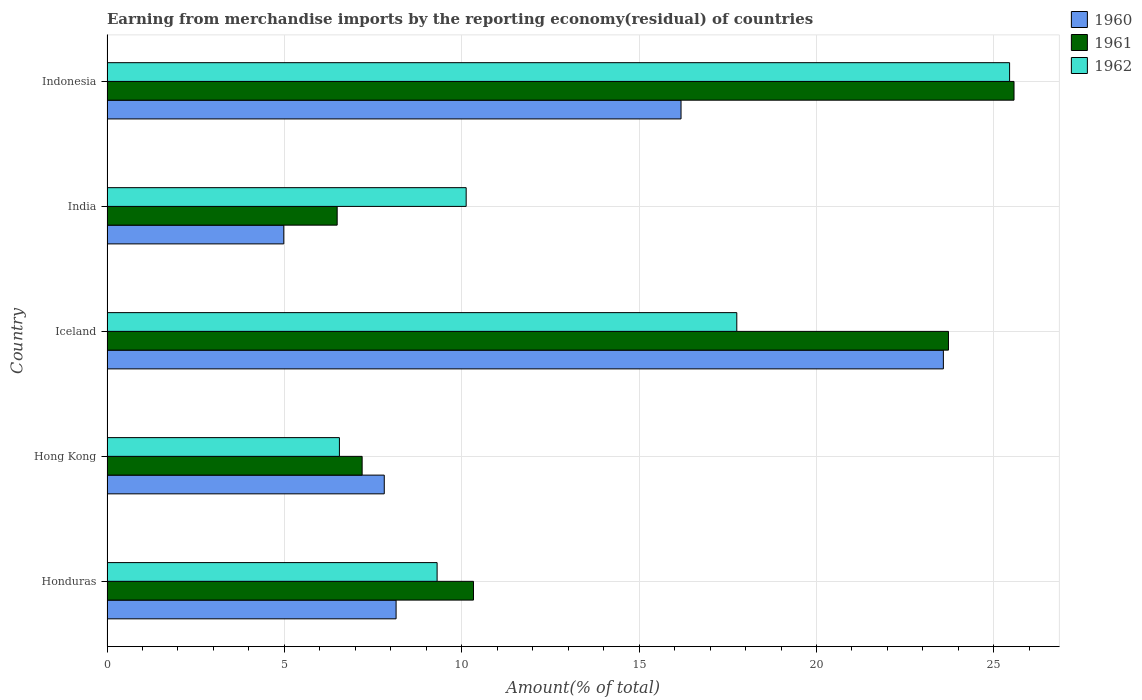How many different coloured bars are there?
Offer a very short reply. 3. Are the number of bars per tick equal to the number of legend labels?
Offer a terse response. Yes. Are the number of bars on each tick of the Y-axis equal?
Offer a very short reply. Yes. What is the label of the 1st group of bars from the top?
Ensure brevity in your answer.  Indonesia. In how many cases, is the number of bars for a given country not equal to the number of legend labels?
Keep it short and to the point. 0. What is the percentage of amount earned from merchandise imports in 1962 in Indonesia?
Offer a terse response. 25.44. Across all countries, what is the maximum percentage of amount earned from merchandise imports in 1962?
Keep it short and to the point. 25.44. Across all countries, what is the minimum percentage of amount earned from merchandise imports in 1962?
Offer a terse response. 6.55. In which country was the percentage of amount earned from merchandise imports in 1962 minimum?
Offer a very short reply. Hong Kong. What is the total percentage of amount earned from merchandise imports in 1962 in the graph?
Provide a succinct answer. 69.18. What is the difference between the percentage of amount earned from merchandise imports in 1961 in Honduras and that in India?
Your response must be concise. 3.84. What is the difference between the percentage of amount earned from merchandise imports in 1962 in Honduras and the percentage of amount earned from merchandise imports in 1961 in Iceland?
Make the answer very short. -14.41. What is the average percentage of amount earned from merchandise imports in 1960 per country?
Your response must be concise. 12.14. What is the difference between the percentage of amount earned from merchandise imports in 1960 and percentage of amount earned from merchandise imports in 1962 in Hong Kong?
Offer a terse response. 1.26. What is the ratio of the percentage of amount earned from merchandise imports in 1962 in Honduras to that in India?
Provide a succinct answer. 0.92. What is the difference between the highest and the second highest percentage of amount earned from merchandise imports in 1962?
Keep it short and to the point. 7.69. What is the difference between the highest and the lowest percentage of amount earned from merchandise imports in 1962?
Give a very brief answer. 18.89. Is the sum of the percentage of amount earned from merchandise imports in 1961 in Hong Kong and Iceland greater than the maximum percentage of amount earned from merchandise imports in 1960 across all countries?
Ensure brevity in your answer.  Yes. What does the 3rd bar from the bottom in Hong Kong represents?
Offer a terse response. 1962. How many countries are there in the graph?
Offer a very short reply. 5. Are the values on the major ticks of X-axis written in scientific E-notation?
Your answer should be compact. No. Does the graph contain any zero values?
Ensure brevity in your answer.  No. Does the graph contain grids?
Your response must be concise. Yes. How are the legend labels stacked?
Give a very brief answer. Vertical. What is the title of the graph?
Ensure brevity in your answer.  Earning from merchandise imports by the reporting economy(residual) of countries. What is the label or title of the X-axis?
Provide a succinct answer. Amount(% of total). What is the Amount(% of total) in 1960 in Honduras?
Provide a succinct answer. 8.15. What is the Amount(% of total) of 1961 in Honduras?
Provide a succinct answer. 10.33. What is the Amount(% of total) of 1962 in Honduras?
Provide a short and direct response. 9.31. What is the Amount(% of total) in 1960 in Hong Kong?
Your response must be concise. 7.82. What is the Amount(% of total) of 1961 in Hong Kong?
Make the answer very short. 7.19. What is the Amount(% of total) in 1962 in Hong Kong?
Your answer should be compact. 6.55. What is the Amount(% of total) in 1960 in Iceland?
Offer a very short reply. 23.58. What is the Amount(% of total) in 1961 in Iceland?
Offer a very short reply. 23.72. What is the Amount(% of total) of 1962 in Iceland?
Your response must be concise. 17.75. What is the Amount(% of total) in 1960 in India?
Provide a succinct answer. 4.98. What is the Amount(% of total) of 1961 in India?
Your answer should be very brief. 6.49. What is the Amount(% of total) of 1962 in India?
Your answer should be very brief. 10.12. What is the Amount(% of total) of 1960 in Indonesia?
Your answer should be compact. 16.18. What is the Amount(% of total) of 1961 in Indonesia?
Offer a terse response. 25.57. What is the Amount(% of total) in 1962 in Indonesia?
Your response must be concise. 25.44. Across all countries, what is the maximum Amount(% of total) in 1960?
Offer a very short reply. 23.58. Across all countries, what is the maximum Amount(% of total) in 1961?
Your answer should be very brief. 25.57. Across all countries, what is the maximum Amount(% of total) of 1962?
Provide a short and direct response. 25.44. Across all countries, what is the minimum Amount(% of total) of 1960?
Give a very brief answer. 4.98. Across all countries, what is the minimum Amount(% of total) in 1961?
Give a very brief answer. 6.49. Across all countries, what is the minimum Amount(% of total) in 1962?
Your response must be concise. 6.55. What is the total Amount(% of total) of 1960 in the graph?
Offer a very short reply. 60.71. What is the total Amount(% of total) in 1961 in the graph?
Your response must be concise. 73.3. What is the total Amount(% of total) of 1962 in the graph?
Provide a succinct answer. 69.18. What is the difference between the Amount(% of total) in 1961 in Honduras and that in Hong Kong?
Your answer should be very brief. 3.14. What is the difference between the Amount(% of total) of 1962 in Honduras and that in Hong Kong?
Your answer should be compact. 2.75. What is the difference between the Amount(% of total) in 1960 in Honduras and that in Iceland?
Provide a short and direct response. -15.43. What is the difference between the Amount(% of total) of 1961 in Honduras and that in Iceland?
Ensure brevity in your answer.  -13.39. What is the difference between the Amount(% of total) of 1962 in Honduras and that in Iceland?
Your response must be concise. -8.45. What is the difference between the Amount(% of total) in 1960 in Honduras and that in India?
Your answer should be compact. 3.17. What is the difference between the Amount(% of total) of 1961 in Honduras and that in India?
Provide a succinct answer. 3.84. What is the difference between the Amount(% of total) of 1962 in Honduras and that in India?
Give a very brief answer. -0.82. What is the difference between the Amount(% of total) of 1960 in Honduras and that in Indonesia?
Provide a succinct answer. -8.03. What is the difference between the Amount(% of total) of 1961 in Honduras and that in Indonesia?
Keep it short and to the point. -15.24. What is the difference between the Amount(% of total) in 1962 in Honduras and that in Indonesia?
Give a very brief answer. -16.14. What is the difference between the Amount(% of total) of 1960 in Hong Kong and that in Iceland?
Your answer should be compact. -15.76. What is the difference between the Amount(% of total) in 1961 in Hong Kong and that in Iceland?
Offer a very short reply. -16.53. What is the difference between the Amount(% of total) in 1962 in Hong Kong and that in Iceland?
Offer a terse response. -11.2. What is the difference between the Amount(% of total) of 1960 in Hong Kong and that in India?
Give a very brief answer. 2.83. What is the difference between the Amount(% of total) of 1961 in Hong Kong and that in India?
Your response must be concise. 0.7. What is the difference between the Amount(% of total) of 1962 in Hong Kong and that in India?
Your answer should be very brief. -3.57. What is the difference between the Amount(% of total) in 1960 in Hong Kong and that in Indonesia?
Provide a short and direct response. -8.37. What is the difference between the Amount(% of total) of 1961 in Hong Kong and that in Indonesia?
Keep it short and to the point. -18.38. What is the difference between the Amount(% of total) in 1962 in Hong Kong and that in Indonesia?
Your answer should be compact. -18.89. What is the difference between the Amount(% of total) in 1960 in Iceland and that in India?
Your response must be concise. 18.59. What is the difference between the Amount(% of total) of 1961 in Iceland and that in India?
Provide a short and direct response. 17.23. What is the difference between the Amount(% of total) in 1962 in Iceland and that in India?
Ensure brevity in your answer.  7.63. What is the difference between the Amount(% of total) of 1960 in Iceland and that in Indonesia?
Give a very brief answer. 7.4. What is the difference between the Amount(% of total) of 1961 in Iceland and that in Indonesia?
Your answer should be compact. -1.85. What is the difference between the Amount(% of total) in 1962 in Iceland and that in Indonesia?
Your answer should be very brief. -7.69. What is the difference between the Amount(% of total) of 1960 in India and that in Indonesia?
Your response must be concise. -11.2. What is the difference between the Amount(% of total) in 1961 in India and that in Indonesia?
Your answer should be compact. -19.08. What is the difference between the Amount(% of total) of 1962 in India and that in Indonesia?
Give a very brief answer. -15.32. What is the difference between the Amount(% of total) of 1960 in Honduras and the Amount(% of total) of 1961 in Hong Kong?
Your response must be concise. 0.96. What is the difference between the Amount(% of total) in 1960 in Honduras and the Amount(% of total) in 1962 in Hong Kong?
Provide a succinct answer. 1.6. What is the difference between the Amount(% of total) in 1961 in Honduras and the Amount(% of total) in 1962 in Hong Kong?
Make the answer very short. 3.78. What is the difference between the Amount(% of total) of 1960 in Honduras and the Amount(% of total) of 1961 in Iceland?
Ensure brevity in your answer.  -15.57. What is the difference between the Amount(% of total) of 1960 in Honduras and the Amount(% of total) of 1962 in Iceland?
Make the answer very short. -9.6. What is the difference between the Amount(% of total) of 1961 in Honduras and the Amount(% of total) of 1962 in Iceland?
Offer a very short reply. -7.42. What is the difference between the Amount(% of total) of 1960 in Honduras and the Amount(% of total) of 1961 in India?
Offer a very short reply. 1.66. What is the difference between the Amount(% of total) in 1960 in Honduras and the Amount(% of total) in 1962 in India?
Offer a terse response. -1.98. What is the difference between the Amount(% of total) in 1961 in Honduras and the Amount(% of total) in 1962 in India?
Give a very brief answer. 0.21. What is the difference between the Amount(% of total) of 1960 in Honduras and the Amount(% of total) of 1961 in Indonesia?
Ensure brevity in your answer.  -17.42. What is the difference between the Amount(% of total) of 1960 in Honduras and the Amount(% of total) of 1962 in Indonesia?
Keep it short and to the point. -17.29. What is the difference between the Amount(% of total) in 1961 in Honduras and the Amount(% of total) in 1962 in Indonesia?
Ensure brevity in your answer.  -15.11. What is the difference between the Amount(% of total) in 1960 in Hong Kong and the Amount(% of total) in 1961 in Iceland?
Provide a succinct answer. -15.9. What is the difference between the Amount(% of total) of 1960 in Hong Kong and the Amount(% of total) of 1962 in Iceland?
Your answer should be very brief. -9.94. What is the difference between the Amount(% of total) of 1961 in Hong Kong and the Amount(% of total) of 1962 in Iceland?
Your answer should be very brief. -10.56. What is the difference between the Amount(% of total) of 1960 in Hong Kong and the Amount(% of total) of 1961 in India?
Your answer should be compact. 1.33. What is the difference between the Amount(% of total) in 1960 in Hong Kong and the Amount(% of total) in 1962 in India?
Ensure brevity in your answer.  -2.31. What is the difference between the Amount(% of total) of 1961 in Hong Kong and the Amount(% of total) of 1962 in India?
Provide a short and direct response. -2.93. What is the difference between the Amount(% of total) of 1960 in Hong Kong and the Amount(% of total) of 1961 in Indonesia?
Offer a terse response. -17.75. What is the difference between the Amount(% of total) in 1960 in Hong Kong and the Amount(% of total) in 1962 in Indonesia?
Give a very brief answer. -17.63. What is the difference between the Amount(% of total) of 1961 in Hong Kong and the Amount(% of total) of 1962 in Indonesia?
Your answer should be compact. -18.25. What is the difference between the Amount(% of total) of 1960 in Iceland and the Amount(% of total) of 1961 in India?
Make the answer very short. 17.09. What is the difference between the Amount(% of total) in 1960 in Iceland and the Amount(% of total) in 1962 in India?
Your answer should be very brief. 13.45. What is the difference between the Amount(% of total) in 1961 in Iceland and the Amount(% of total) in 1962 in India?
Offer a very short reply. 13.6. What is the difference between the Amount(% of total) of 1960 in Iceland and the Amount(% of total) of 1961 in Indonesia?
Keep it short and to the point. -1.99. What is the difference between the Amount(% of total) in 1960 in Iceland and the Amount(% of total) in 1962 in Indonesia?
Ensure brevity in your answer.  -1.87. What is the difference between the Amount(% of total) of 1961 in Iceland and the Amount(% of total) of 1962 in Indonesia?
Your answer should be compact. -1.72. What is the difference between the Amount(% of total) of 1960 in India and the Amount(% of total) of 1961 in Indonesia?
Ensure brevity in your answer.  -20.58. What is the difference between the Amount(% of total) in 1960 in India and the Amount(% of total) in 1962 in Indonesia?
Offer a terse response. -20.46. What is the difference between the Amount(% of total) in 1961 in India and the Amount(% of total) in 1962 in Indonesia?
Make the answer very short. -18.95. What is the average Amount(% of total) of 1960 per country?
Your answer should be compact. 12.14. What is the average Amount(% of total) of 1961 per country?
Ensure brevity in your answer.  14.66. What is the average Amount(% of total) in 1962 per country?
Offer a very short reply. 13.84. What is the difference between the Amount(% of total) of 1960 and Amount(% of total) of 1961 in Honduras?
Give a very brief answer. -2.18. What is the difference between the Amount(% of total) in 1960 and Amount(% of total) in 1962 in Honduras?
Your answer should be very brief. -1.16. What is the difference between the Amount(% of total) of 1961 and Amount(% of total) of 1962 in Honduras?
Make the answer very short. 1.03. What is the difference between the Amount(% of total) in 1960 and Amount(% of total) in 1961 in Hong Kong?
Provide a succinct answer. 0.62. What is the difference between the Amount(% of total) in 1960 and Amount(% of total) in 1962 in Hong Kong?
Offer a very short reply. 1.26. What is the difference between the Amount(% of total) in 1961 and Amount(% of total) in 1962 in Hong Kong?
Provide a short and direct response. 0.64. What is the difference between the Amount(% of total) of 1960 and Amount(% of total) of 1961 in Iceland?
Your answer should be very brief. -0.14. What is the difference between the Amount(% of total) of 1960 and Amount(% of total) of 1962 in Iceland?
Your answer should be very brief. 5.82. What is the difference between the Amount(% of total) in 1961 and Amount(% of total) in 1962 in Iceland?
Offer a very short reply. 5.97. What is the difference between the Amount(% of total) of 1960 and Amount(% of total) of 1961 in India?
Make the answer very short. -1.5. What is the difference between the Amount(% of total) in 1960 and Amount(% of total) in 1962 in India?
Provide a succinct answer. -5.14. What is the difference between the Amount(% of total) in 1961 and Amount(% of total) in 1962 in India?
Offer a terse response. -3.64. What is the difference between the Amount(% of total) in 1960 and Amount(% of total) in 1961 in Indonesia?
Make the answer very short. -9.39. What is the difference between the Amount(% of total) in 1960 and Amount(% of total) in 1962 in Indonesia?
Give a very brief answer. -9.26. What is the difference between the Amount(% of total) of 1961 and Amount(% of total) of 1962 in Indonesia?
Your answer should be very brief. 0.12. What is the ratio of the Amount(% of total) in 1960 in Honduras to that in Hong Kong?
Ensure brevity in your answer.  1.04. What is the ratio of the Amount(% of total) in 1961 in Honduras to that in Hong Kong?
Make the answer very short. 1.44. What is the ratio of the Amount(% of total) of 1962 in Honduras to that in Hong Kong?
Your response must be concise. 1.42. What is the ratio of the Amount(% of total) in 1960 in Honduras to that in Iceland?
Offer a very short reply. 0.35. What is the ratio of the Amount(% of total) of 1961 in Honduras to that in Iceland?
Your answer should be compact. 0.44. What is the ratio of the Amount(% of total) in 1962 in Honduras to that in Iceland?
Offer a very short reply. 0.52. What is the ratio of the Amount(% of total) of 1960 in Honduras to that in India?
Your answer should be compact. 1.64. What is the ratio of the Amount(% of total) of 1961 in Honduras to that in India?
Ensure brevity in your answer.  1.59. What is the ratio of the Amount(% of total) in 1962 in Honduras to that in India?
Your answer should be very brief. 0.92. What is the ratio of the Amount(% of total) of 1960 in Honduras to that in Indonesia?
Keep it short and to the point. 0.5. What is the ratio of the Amount(% of total) of 1961 in Honduras to that in Indonesia?
Offer a very short reply. 0.4. What is the ratio of the Amount(% of total) in 1962 in Honduras to that in Indonesia?
Your response must be concise. 0.37. What is the ratio of the Amount(% of total) in 1960 in Hong Kong to that in Iceland?
Your answer should be very brief. 0.33. What is the ratio of the Amount(% of total) in 1961 in Hong Kong to that in Iceland?
Give a very brief answer. 0.3. What is the ratio of the Amount(% of total) in 1962 in Hong Kong to that in Iceland?
Keep it short and to the point. 0.37. What is the ratio of the Amount(% of total) of 1960 in Hong Kong to that in India?
Make the answer very short. 1.57. What is the ratio of the Amount(% of total) in 1961 in Hong Kong to that in India?
Ensure brevity in your answer.  1.11. What is the ratio of the Amount(% of total) of 1962 in Hong Kong to that in India?
Ensure brevity in your answer.  0.65. What is the ratio of the Amount(% of total) of 1960 in Hong Kong to that in Indonesia?
Your answer should be very brief. 0.48. What is the ratio of the Amount(% of total) in 1961 in Hong Kong to that in Indonesia?
Provide a succinct answer. 0.28. What is the ratio of the Amount(% of total) in 1962 in Hong Kong to that in Indonesia?
Provide a succinct answer. 0.26. What is the ratio of the Amount(% of total) in 1960 in Iceland to that in India?
Ensure brevity in your answer.  4.73. What is the ratio of the Amount(% of total) in 1961 in Iceland to that in India?
Provide a succinct answer. 3.66. What is the ratio of the Amount(% of total) in 1962 in Iceland to that in India?
Give a very brief answer. 1.75. What is the ratio of the Amount(% of total) in 1960 in Iceland to that in Indonesia?
Ensure brevity in your answer.  1.46. What is the ratio of the Amount(% of total) in 1961 in Iceland to that in Indonesia?
Offer a very short reply. 0.93. What is the ratio of the Amount(% of total) in 1962 in Iceland to that in Indonesia?
Ensure brevity in your answer.  0.7. What is the ratio of the Amount(% of total) of 1960 in India to that in Indonesia?
Make the answer very short. 0.31. What is the ratio of the Amount(% of total) in 1961 in India to that in Indonesia?
Offer a very short reply. 0.25. What is the ratio of the Amount(% of total) of 1962 in India to that in Indonesia?
Your response must be concise. 0.4. What is the difference between the highest and the second highest Amount(% of total) in 1960?
Your response must be concise. 7.4. What is the difference between the highest and the second highest Amount(% of total) of 1961?
Your answer should be very brief. 1.85. What is the difference between the highest and the second highest Amount(% of total) in 1962?
Your answer should be compact. 7.69. What is the difference between the highest and the lowest Amount(% of total) of 1960?
Provide a succinct answer. 18.59. What is the difference between the highest and the lowest Amount(% of total) of 1961?
Provide a succinct answer. 19.08. What is the difference between the highest and the lowest Amount(% of total) of 1962?
Offer a very short reply. 18.89. 